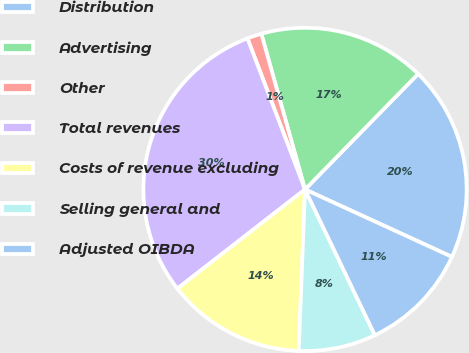Convert chart. <chart><loc_0><loc_0><loc_500><loc_500><pie_chart><fcel>Distribution<fcel>Advertising<fcel>Other<fcel>Total revenues<fcel>Costs of revenue excluding<fcel>Selling general and<fcel>Adjusted OIBDA<nl><fcel>19.52%<fcel>16.69%<fcel>1.44%<fcel>29.72%<fcel>13.87%<fcel>7.73%<fcel>11.04%<nl></chart> 